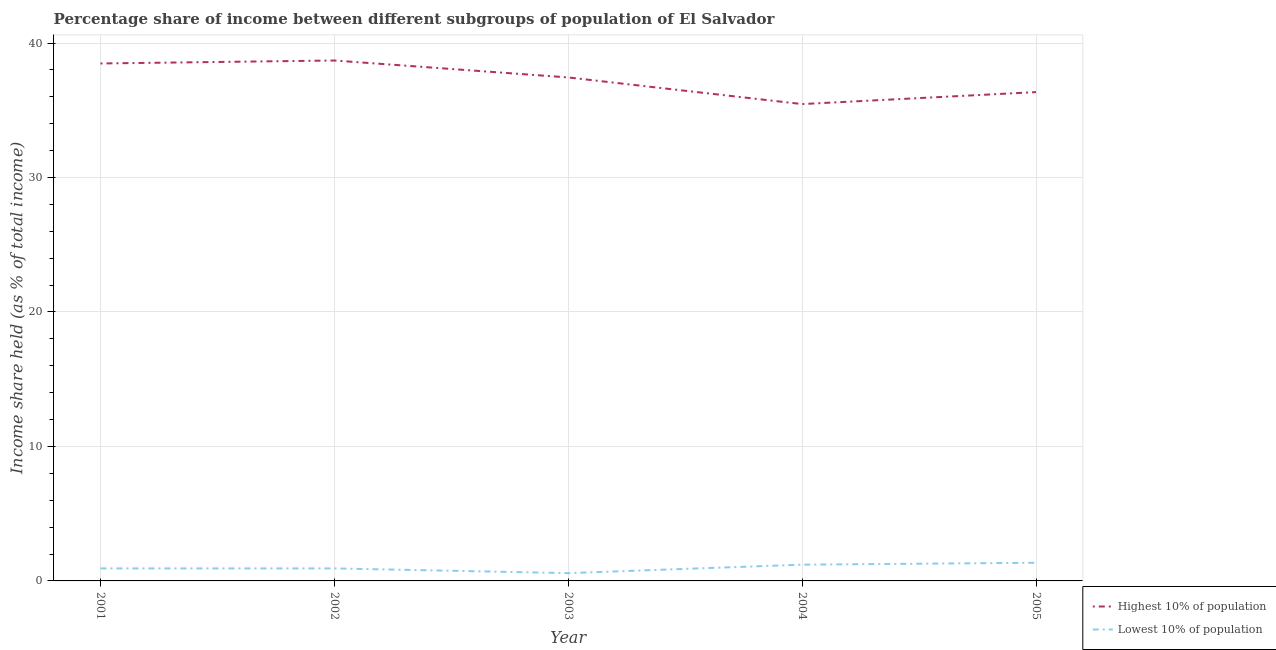How many different coloured lines are there?
Make the answer very short. 2. Does the line corresponding to income share held by highest 10% of the population intersect with the line corresponding to income share held by lowest 10% of the population?
Keep it short and to the point. No. Is the number of lines equal to the number of legend labels?
Your answer should be very brief. Yes. What is the income share held by highest 10% of the population in 2005?
Keep it short and to the point. 36.35. Across all years, what is the maximum income share held by highest 10% of the population?
Provide a short and direct response. 38.7. Across all years, what is the minimum income share held by lowest 10% of the population?
Provide a succinct answer. 0.58. In which year was the income share held by lowest 10% of the population maximum?
Give a very brief answer. 2005. In which year was the income share held by highest 10% of the population minimum?
Provide a short and direct response. 2004. What is the difference between the income share held by highest 10% of the population in 2003 and that in 2004?
Give a very brief answer. 1.98. What is the difference between the income share held by lowest 10% of the population in 2004 and the income share held by highest 10% of the population in 2003?
Keep it short and to the point. -36.23. What is the average income share held by highest 10% of the population per year?
Give a very brief answer. 37.29. In the year 2002, what is the difference between the income share held by lowest 10% of the population and income share held by highest 10% of the population?
Your response must be concise. -37.77. What is the ratio of the income share held by lowest 10% of the population in 2001 to that in 2003?
Offer a very short reply. 1.6. What is the difference between the highest and the second highest income share held by highest 10% of the population?
Ensure brevity in your answer.  0.22. What is the difference between the highest and the lowest income share held by highest 10% of the population?
Provide a short and direct response. 3.24. In how many years, is the income share held by lowest 10% of the population greater than the average income share held by lowest 10% of the population taken over all years?
Ensure brevity in your answer.  2. Is the sum of the income share held by highest 10% of the population in 2003 and 2005 greater than the maximum income share held by lowest 10% of the population across all years?
Offer a very short reply. Yes. Is the income share held by highest 10% of the population strictly greater than the income share held by lowest 10% of the population over the years?
Give a very brief answer. Yes. Is the income share held by lowest 10% of the population strictly less than the income share held by highest 10% of the population over the years?
Your answer should be compact. Yes. How many lines are there?
Your answer should be very brief. 2. Are the values on the major ticks of Y-axis written in scientific E-notation?
Your answer should be very brief. No. Does the graph contain any zero values?
Give a very brief answer. No. Does the graph contain grids?
Keep it short and to the point. Yes. Where does the legend appear in the graph?
Your answer should be compact. Bottom right. How are the legend labels stacked?
Keep it short and to the point. Vertical. What is the title of the graph?
Keep it short and to the point. Percentage share of income between different subgroups of population of El Salvador. Does "From World Bank" appear as one of the legend labels in the graph?
Provide a succinct answer. No. What is the label or title of the X-axis?
Give a very brief answer. Year. What is the label or title of the Y-axis?
Provide a succinct answer. Income share held (as % of total income). What is the Income share held (as % of total income) of Highest 10% of population in 2001?
Keep it short and to the point. 38.48. What is the Income share held (as % of total income) of Lowest 10% of population in 2001?
Provide a succinct answer. 0.93. What is the Income share held (as % of total income) of Highest 10% of population in 2002?
Ensure brevity in your answer.  38.7. What is the Income share held (as % of total income) in Highest 10% of population in 2003?
Give a very brief answer. 37.44. What is the Income share held (as % of total income) in Lowest 10% of population in 2003?
Give a very brief answer. 0.58. What is the Income share held (as % of total income) of Highest 10% of population in 2004?
Ensure brevity in your answer.  35.46. What is the Income share held (as % of total income) in Lowest 10% of population in 2004?
Your answer should be very brief. 1.21. What is the Income share held (as % of total income) of Highest 10% of population in 2005?
Your response must be concise. 36.35. What is the Income share held (as % of total income) of Lowest 10% of population in 2005?
Provide a short and direct response. 1.35. Across all years, what is the maximum Income share held (as % of total income) in Highest 10% of population?
Your response must be concise. 38.7. Across all years, what is the maximum Income share held (as % of total income) of Lowest 10% of population?
Make the answer very short. 1.35. Across all years, what is the minimum Income share held (as % of total income) in Highest 10% of population?
Give a very brief answer. 35.46. Across all years, what is the minimum Income share held (as % of total income) of Lowest 10% of population?
Ensure brevity in your answer.  0.58. What is the total Income share held (as % of total income) in Highest 10% of population in the graph?
Offer a terse response. 186.43. What is the total Income share held (as % of total income) in Lowest 10% of population in the graph?
Offer a very short reply. 5. What is the difference between the Income share held (as % of total income) in Highest 10% of population in 2001 and that in 2002?
Your answer should be very brief. -0.22. What is the difference between the Income share held (as % of total income) in Highest 10% of population in 2001 and that in 2003?
Keep it short and to the point. 1.04. What is the difference between the Income share held (as % of total income) in Lowest 10% of population in 2001 and that in 2003?
Offer a terse response. 0.35. What is the difference between the Income share held (as % of total income) of Highest 10% of population in 2001 and that in 2004?
Your answer should be very brief. 3.02. What is the difference between the Income share held (as % of total income) in Lowest 10% of population in 2001 and that in 2004?
Offer a terse response. -0.28. What is the difference between the Income share held (as % of total income) in Highest 10% of population in 2001 and that in 2005?
Your answer should be very brief. 2.13. What is the difference between the Income share held (as % of total income) of Lowest 10% of population in 2001 and that in 2005?
Give a very brief answer. -0.42. What is the difference between the Income share held (as % of total income) in Highest 10% of population in 2002 and that in 2003?
Your answer should be very brief. 1.26. What is the difference between the Income share held (as % of total income) of Highest 10% of population in 2002 and that in 2004?
Give a very brief answer. 3.24. What is the difference between the Income share held (as % of total income) in Lowest 10% of population in 2002 and that in 2004?
Your answer should be compact. -0.28. What is the difference between the Income share held (as % of total income) in Highest 10% of population in 2002 and that in 2005?
Provide a short and direct response. 2.35. What is the difference between the Income share held (as % of total income) in Lowest 10% of population in 2002 and that in 2005?
Give a very brief answer. -0.42. What is the difference between the Income share held (as % of total income) of Highest 10% of population in 2003 and that in 2004?
Make the answer very short. 1.98. What is the difference between the Income share held (as % of total income) in Lowest 10% of population in 2003 and that in 2004?
Provide a short and direct response. -0.63. What is the difference between the Income share held (as % of total income) of Highest 10% of population in 2003 and that in 2005?
Provide a succinct answer. 1.09. What is the difference between the Income share held (as % of total income) in Lowest 10% of population in 2003 and that in 2005?
Offer a terse response. -0.77. What is the difference between the Income share held (as % of total income) in Highest 10% of population in 2004 and that in 2005?
Give a very brief answer. -0.89. What is the difference between the Income share held (as % of total income) in Lowest 10% of population in 2004 and that in 2005?
Offer a very short reply. -0.14. What is the difference between the Income share held (as % of total income) of Highest 10% of population in 2001 and the Income share held (as % of total income) of Lowest 10% of population in 2002?
Offer a terse response. 37.55. What is the difference between the Income share held (as % of total income) of Highest 10% of population in 2001 and the Income share held (as % of total income) of Lowest 10% of population in 2003?
Your answer should be very brief. 37.9. What is the difference between the Income share held (as % of total income) of Highest 10% of population in 2001 and the Income share held (as % of total income) of Lowest 10% of population in 2004?
Your response must be concise. 37.27. What is the difference between the Income share held (as % of total income) in Highest 10% of population in 2001 and the Income share held (as % of total income) in Lowest 10% of population in 2005?
Offer a terse response. 37.13. What is the difference between the Income share held (as % of total income) of Highest 10% of population in 2002 and the Income share held (as % of total income) of Lowest 10% of population in 2003?
Your answer should be very brief. 38.12. What is the difference between the Income share held (as % of total income) of Highest 10% of population in 2002 and the Income share held (as % of total income) of Lowest 10% of population in 2004?
Make the answer very short. 37.49. What is the difference between the Income share held (as % of total income) of Highest 10% of population in 2002 and the Income share held (as % of total income) of Lowest 10% of population in 2005?
Ensure brevity in your answer.  37.35. What is the difference between the Income share held (as % of total income) in Highest 10% of population in 2003 and the Income share held (as % of total income) in Lowest 10% of population in 2004?
Offer a terse response. 36.23. What is the difference between the Income share held (as % of total income) of Highest 10% of population in 2003 and the Income share held (as % of total income) of Lowest 10% of population in 2005?
Keep it short and to the point. 36.09. What is the difference between the Income share held (as % of total income) in Highest 10% of population in 2004 and the Income share held (as % of total income) in Lowest 10% of population in 2005?
Your response must be concise. 34.11. What is the average Income share held (as % of total income) of Highest 10% of population per year?
Your answer should be compact. 37.29. In the year 2001, what is the difference between the Income share held (as % of total income) of Highest 10% of population and Income share held (as % of total income) of Lowest 10% of population?
Provide a succinct answer. 37.55. In the year 2002, what is the difference between the Income share held (as % of total income) of Highest 10% of population and Income share held (as % of total income) of Lowest 10% of population?
Offer a very short reply. 37.77. In the year 2003, what is the difference between the Income share held (as % of total income) in Highest 10% of population and Income share held (as % of total income) in Lowest 10% of population?
Your answer should be compact. 36.86. In the year 2004, what is the difference between the Income share held (as % of total income) of Highest 10% of population and Income share held (as % of total income) of Lowest 10% of population?
Give a very brief answer. 34.25. In the year 2005, what is the difference between the Income share held (as % of total income) of Highest 10% of population and Income share held (as % of total income) of Lowest 10% of population?
Keep it short and to the point. 35. What is the ratio of the Income share held (as % of total income) in Highest 10% of population in 2001 to that in 2002?
Your response must be concise. 0.99. What is the ratio of the Income share held (as % of total income) of Highest 10% of population in 2001 to that in 2003?
Offer a terse response. 1.03. What is the ratio of the Income share held (as % of total income) in Lowest 10% of population in 2001 to that in 2003?
Your answer should be compact. 1.6. What is the ratio of the Income share held (as % of total income) of Highest 10% of population in 2001 to that in 2004?
Ensure brevity in your answer.  1.09. What is the ratio of the Income share held (as % of total income) of Lowest 10% of population in 2001 to that in 2004?
Give a very brief answer. 0.77. What is the ratio of the Income share held (as % of total income) in Highest 10% of population in 2001 to that in 2005?
Keep it short and to the point. 1.06. What is the ratio of the Income share held (as % of total income) of Lowest 10% of population in 2001 to that in 2005?
Provide a short and direct response. 0.69. What is the ratio of the Income share held (as % of total income) of Highest 10% of population in 2002 to that in 2003?
Make the answer very short. 1.03. What is the ratio of the Income share held (as % of total income) of Lowest 10% of population in 2002 to that in 2003?
Your answer should be very brief. 1.6. What is the ratio of the Income share held (as % of total income) of Highest 10% of population in 2002 to that in 2004?
Make the answer very short. 1.09. What is the ratio of the Income share held (as % of total income) in Lowest 10% of population in 2002 to that in 2004?
Offer a very short reply. 0.77. What is the ratio of the Income share held (as % of total income) of Highest 10% of population in 2002 to that in 2005?
Your answer should be very brief. 1.06. What is the ratio of the Income share held (as % of total income) in Lowest 10% of population in 2002 to that in 2005?
Give a very brief answer. 0.69. What is the ratio of the Income share held (as % of total income) of Highest 10% of population in 2003 to that in 2004?
Your answer should be very brief. 1.06. What is the ratio of the Income share held (as % of total income) in Lowest 10% of population in 2003 to that in 2004?
Your response must be concise. 0.48. What is the ratio of the Income share held (as % of total income) of Highest 10% of population in 2003 to that in 2005?
Ensure brevity in your answer.  1.03. What is the ratio of the Income share held (as % of total income) in Lowest 10% of population in 2003 to that in 2005?
Your answer should be compact. 0.43. What is the ratio of the Income share held (as % of total income) in Highest 10% of population in 2004 to that in 2005?
Your answer should be very brief. 0.98. What is the ratio of the Income share held (as % of total income) of Lowest 10% of population in 2004 to that in 2005?
Provide a succinct answer. 0.9. What is the difference between the highest and the second highest Income share held (as % of total income) in Highest 10% of population?
Keep it short and to the point. 0.22. What is the difference between the highest and the second highest Income share held (as % of total income) of Lowest 10% of population?
Make the answer very short. 0.14. What is the difference between the highest and the lowest Income share held (as % of total income) in Highest 10% of population?
Make the answer very short. 3.24. What is the difference between the highest and the lowest Income share held (as % of total income) of Lowest 10% of population?
Provide a short and direct response. 0.77. 